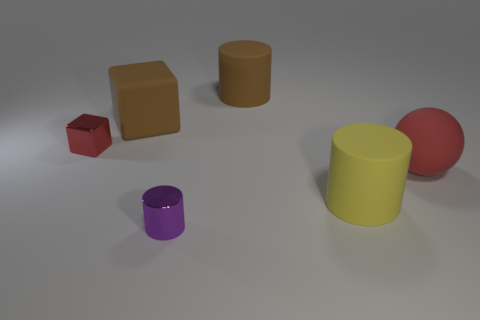Add 2 brown things. How many objects exist? 8 Subtract all blocks. How many objects are left? 4 Subtract 0 red cylinders. How many objects are left? 6 Subtract all brown rubber objects. Subtract all big matte things. How many objects are left? 0 Add 6 brown things. How many brown things are left? 8 Add 2 small gray shiny things. How many small gray shiny things exist? 2 